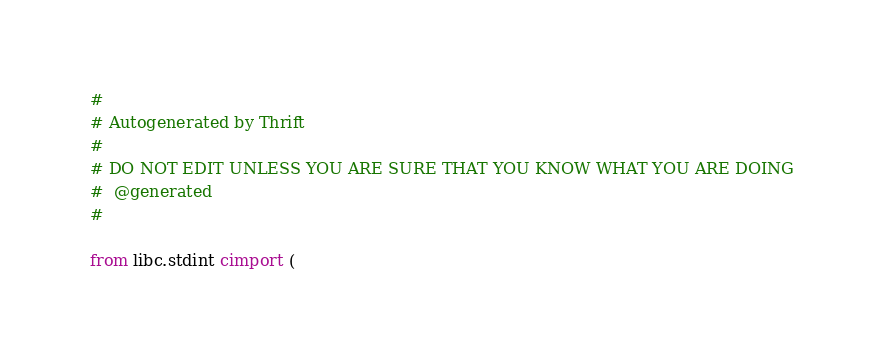Convert code to text. <code><loc_0><loc_0><loc_500><loc_500><_Cython_>#
# Autogenerated by Thrift
#
# DO NOT EDIT UNLESS YOU ARE SURE THAT YOU KNOW WHAT YOU ARE DOING
#  @generated
#

from libc.stdint cimport (</code> 